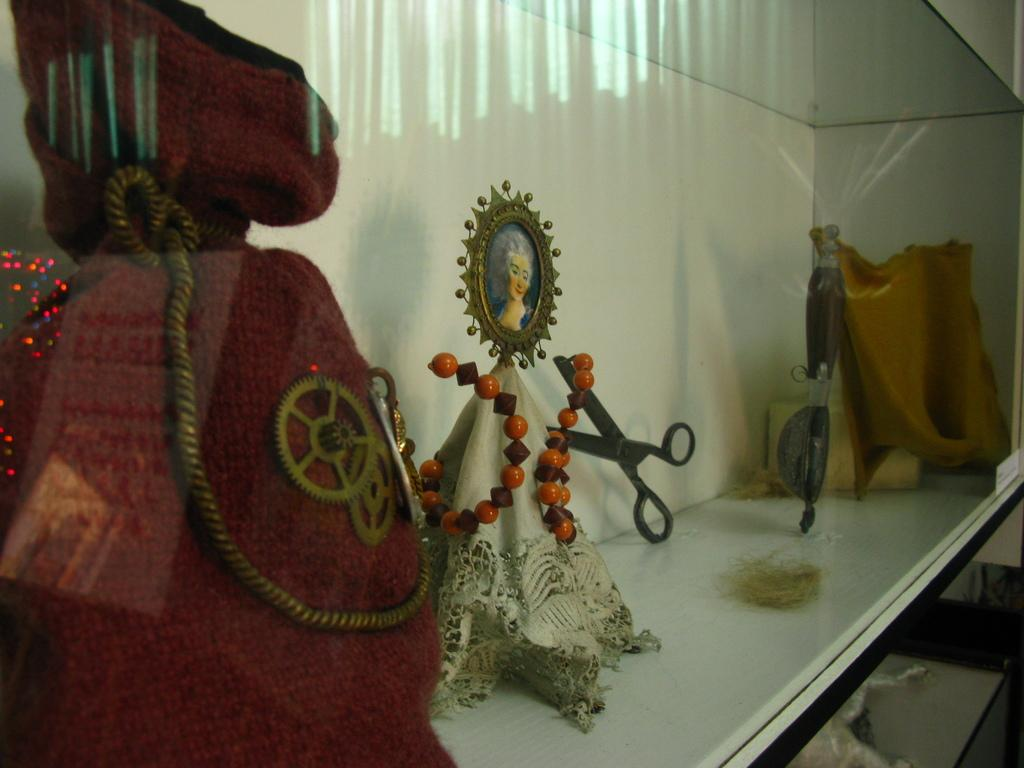What is located in the foreground of the image? There is a red bag and a scissor in the foreground of the image. What else can be seen in the foreground of the image? There are showcase objects inside the glass in the foreground of the image. What type of country is depicted in the image? There is no country depicted in the image; it features a red bag, a scissor, and showcase objects inside a glass. What kind of feast is being prepared in the image? There is no feast being prepared in the image; it only shows a red bag, a scissor, and showcase objects inside a glass. 